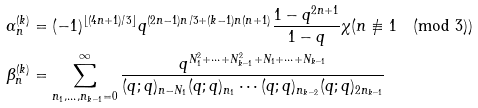<formula> <loc_0><loc_0><loc_500><loc_500>\alpha _ { n } ^ { ( k ) } & = ( - 1 ) ^ { \lfloor ( 4 n + 1 ) / 3 \rfloor } q ^ { ( 2 n - 1 ) n / 3 + ( k - 1 ) n ( n + 1 ) } \frac { 1 - q ^ { 2 n + 1 } } { 1 - q } \chi ( n \not \equiv 1 \pmod { 3 } ) \\ \beta _ { n } ^ { ( k ) } & = \sum _ { n _ { 1 } , \dots , n _ { k - 1 } = 0 } ^ { \infty } \frac { q ^ { N _ { 1 } ^ { 2 } + \cdots + N _ { k - 1 } ^ { 2 } + N _ { 1 } + \cdots + N _ { k - 1 } } } { ( q ; q ) _ { n - N _ { 1 } } ( q ; q ) _ { n _ { 1 } } \cdots ( q ; q ) _ { n _ { k - 2 } } ( q ; q ) _ { 2 n _ { k - 1 } } }</formula> 